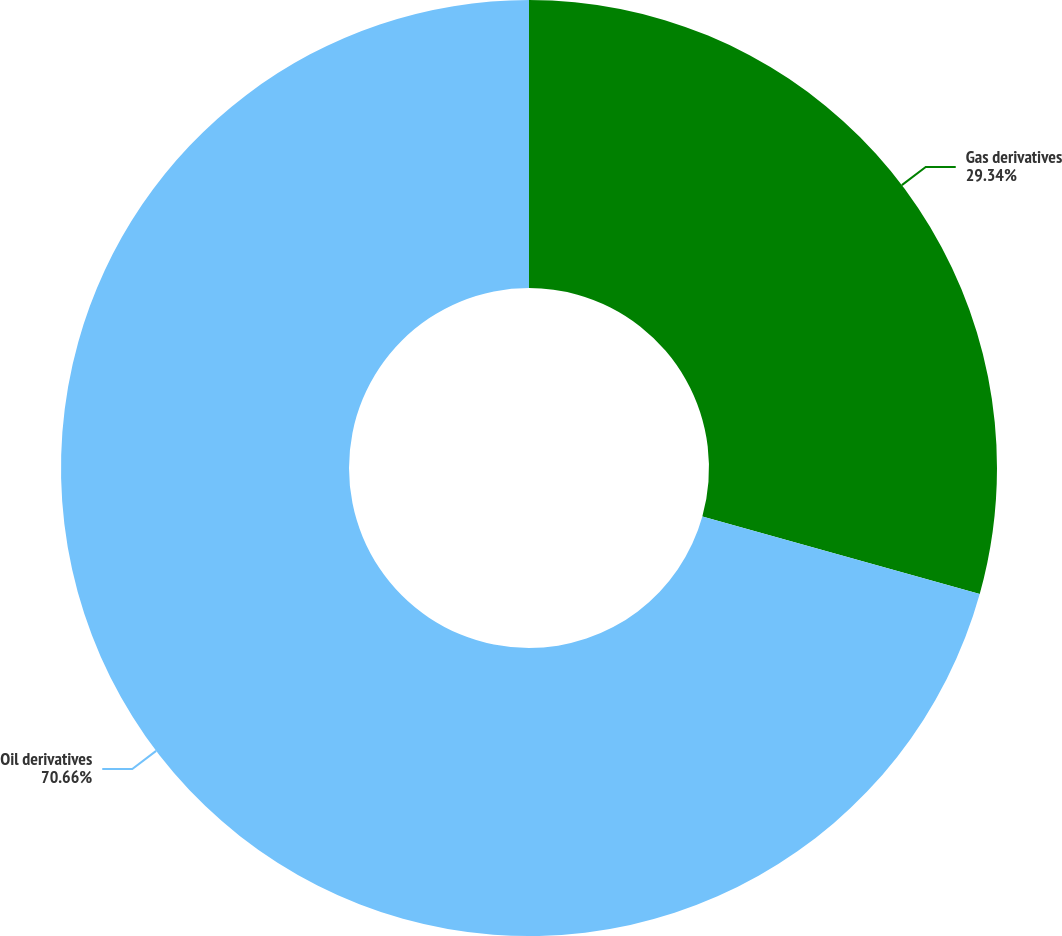Convert chart. <chart><loc_0><loc_0><loc_500><loc_500><pie_chart><fcel>Gas derivatives<fcel>Oil derivatives<nl><fcel>29.34%<fcel>70.66%<nl></chart> 